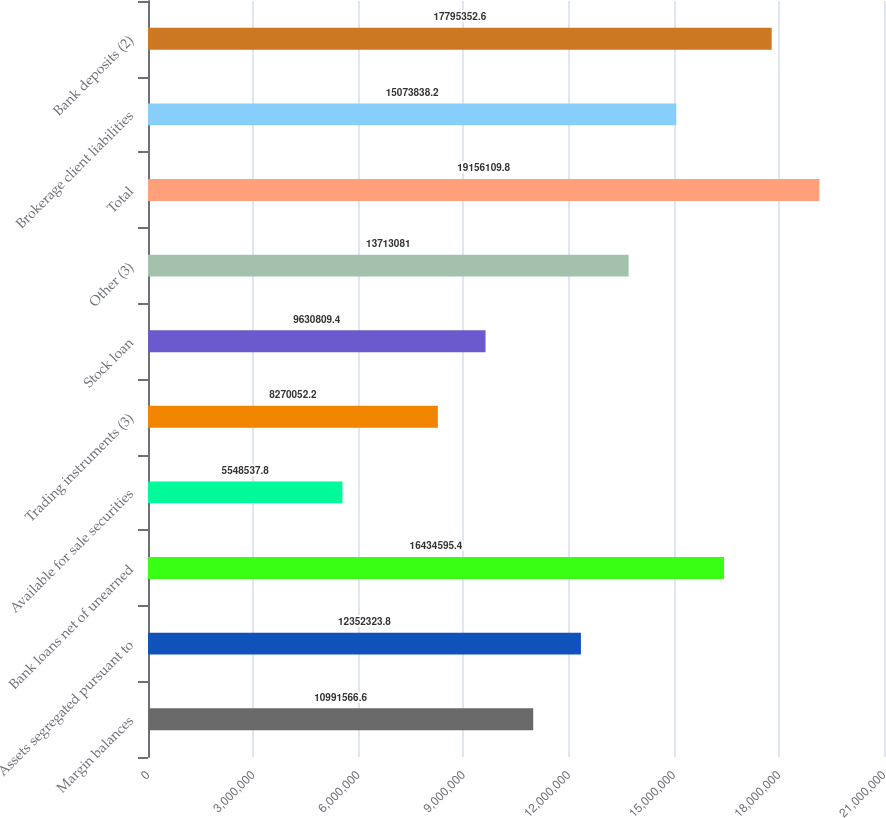<chart> <loc_0><loc_0><loc_500><loc_500><bar_chart><fcel>Margin balances<fcel>Assets segregated pursuant to<fcel>Bank loans net of unearned<fcel>Available for sale securities<fcel>Trading instruments (3)<fcel>Stock loan<fcel>Other (3)<fcel>Total<fcel>Brokerage client liabilities<fcel>Bank deposits (2)<nl><fcel>1.09916e+07<fcel>1.23523e+07<fcel>1.64346e+07<fcel>5.54854e+06<fcel>8.27005e+06<fcel>9.63081e+06<fcel>1.37131e+07<fcel>1.91561e+07<fcel>1.50738e+07<fcel>1.77954e+07<nl></chart> 